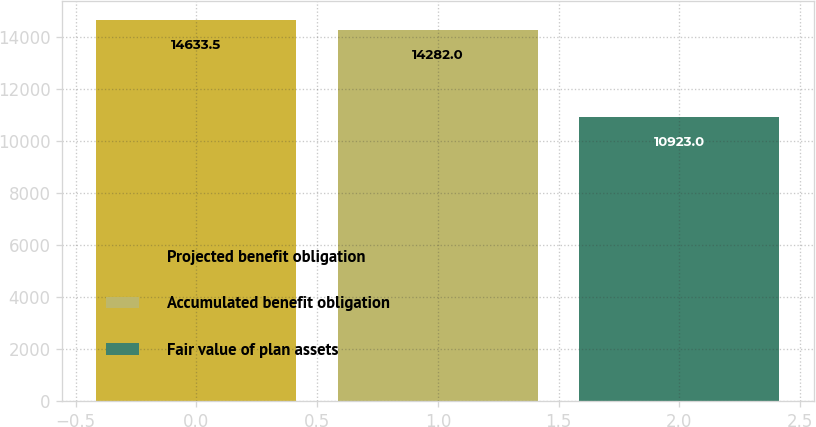Convert chart. <chart><loc_0><loc_0><loc_500><loc_500><bar_chart><fcel>Projected benefit obligation<fcel>Accumulated benefit obligation<fcel>Fair value of plan assets<nl><fcel>14633.5<fcel>14282<fcel>10923<nl></chart> 